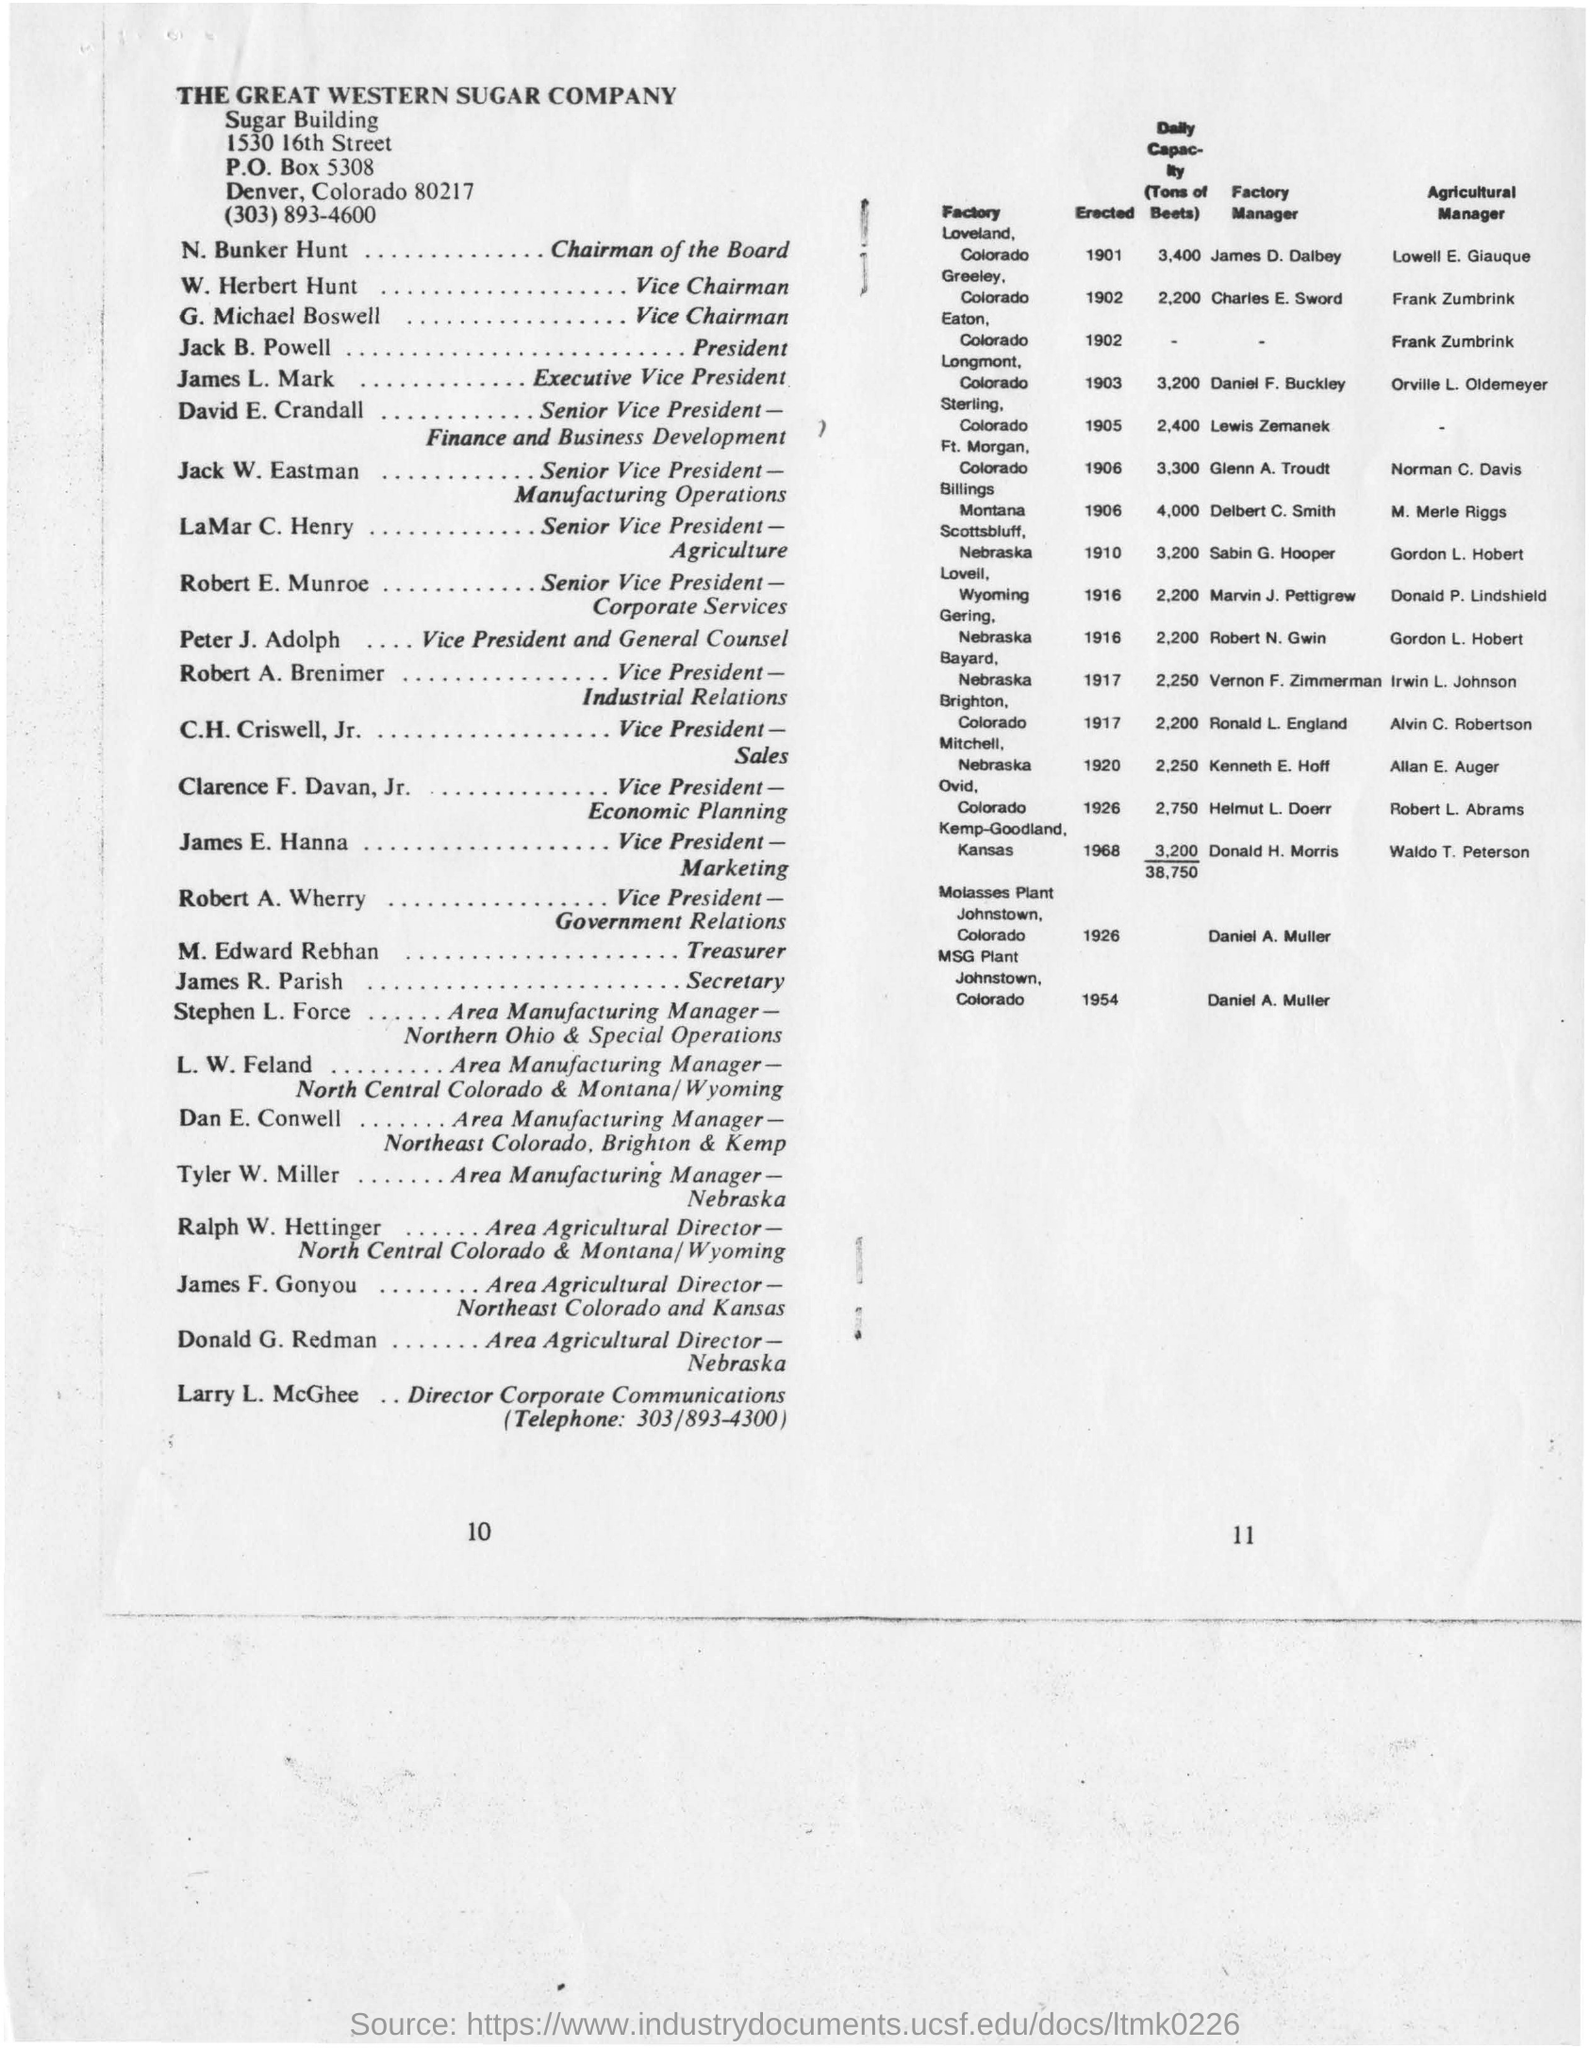Where is THE GREAT WESTERN SUGAR COMPANY located?
Your response must be concise. Denver, Colorado. Who is the Chairman of the Board?
Your answer should be very brief. N. Bunker Hunt. What is the designation of M. Edward Rebhan?
Your answer should be very brief. Treasurer. How much is the daily capacity of Sterling Factory?
Offer a terse response. 2,400. 